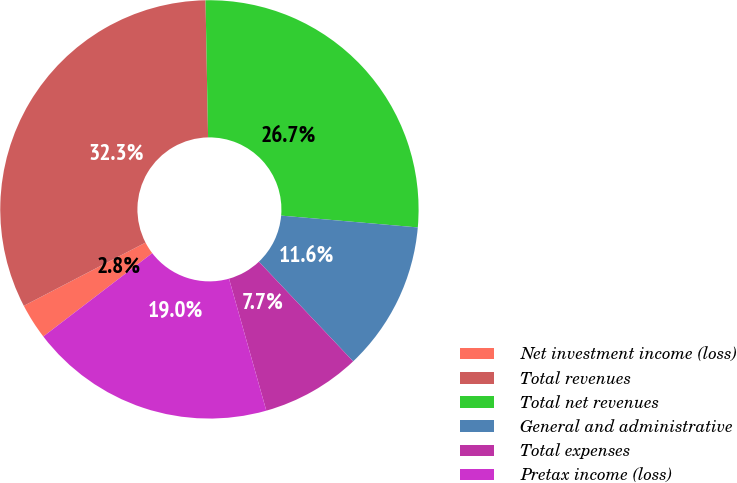<chart> <loc_0><loc_0><loc_500><loc_500><pie_chart><fcel>Net investment income (loss)<fcel>Total revenues<fcel>Total net revenues<fcel>General and administrative<fcel>Total expenses<fcel>Pretax income (loss)<nl><fcel>2.77%<fcel>32.33%<fcel>26.67%<fcel>11.57%<fcel>7.67%<fcel>18.99%<nl></chart> 